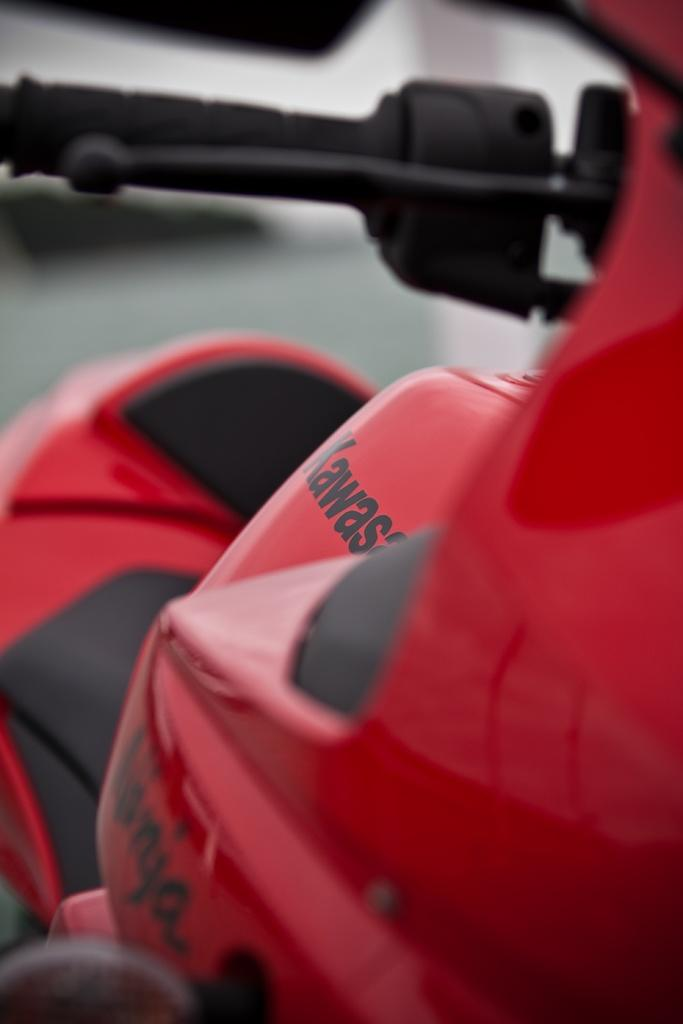What type of vehicle is in the picture? There is a motorcycle in the picture. What color is the motorcycle? The motorcycle is red. What color are the handle and brake of the motorcycle? The handle is black, and the brake is also black. What can be seen on the engine of the motorcycle? There is something written on the engine of the motorcycle. What type of story is being told by the motorcycle in the picture? The motorcycle in the picture is not telling a story; it is an inanimate object. 